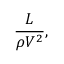<formula> <loc_0><loc_0><loc_500><loc_500>{ \frac { L } { \rho V ^ { 2 } } } ,</formula> 